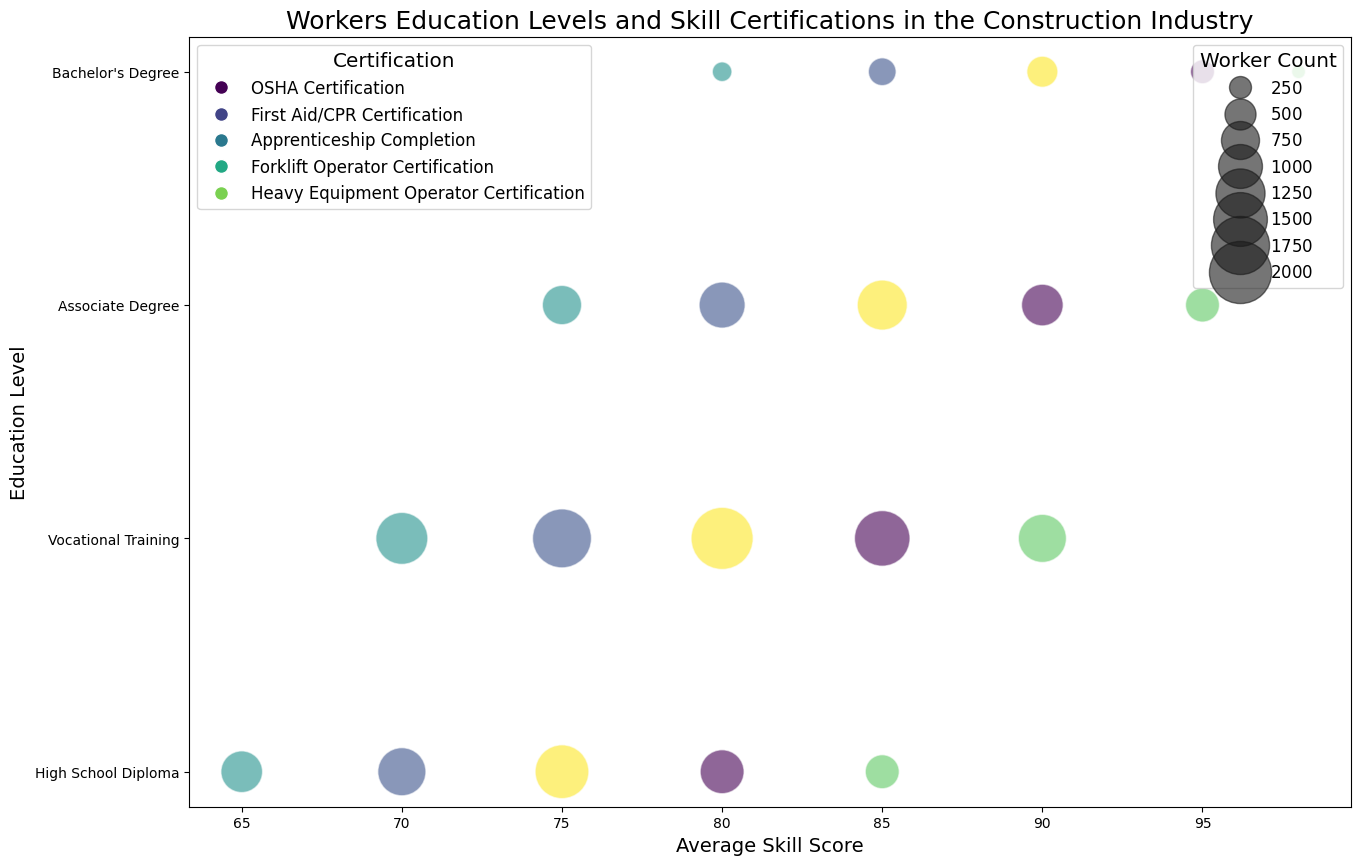Which certification is most common among workers with vocational training? Look for the largest bubble size in the row "Vocational Training." The largest bubble corresponds to "OSHA Certification" with 200 workers.
Answer: OSHA Certification What is the highest average skill score for workers with a bachelor's degree? Check for the maximum value on the x-axis among all bubbles in the "Bachelor's Degree" row. The highest value is 98 for "Heavy Equipment Operator Certification."
Answer: 98 Which education level has the highest average skill score for First Aid/CPR Certification? Compare the positions along the x-axis for "First Aid/CPR Certification" across all education levels. "Bachelor's Degree" has the highest score at 85.
Answer: Bachelor's Degree Between "High School Diploma" and "Associate Degree," which has more workers with Heavy Equipment Operator Certification? Compare the bubble sizes for "High School Diploma" and "Associate Degree" in the "Heavy Equipment Operator Certification" category. "High School Diploma" has 60 workers, and "Associate Degree" has 60 workers.
Answer: Equal What is the total number of workers with OSHA Certification across all education levels? Add the number of workers in the "OSHA Certification" category for all education levels: 150 + 200 + 130 + 50 = 530 workers.
Answer: 530 How much higher is the average skill score for workers with an Associate Degree and Heavy Equipment Operator Certification compared to those with a High School Diploma and the same certification? Subtract the average skill score for "High School Diploma" (85) from "Associate Degree" (95) for "Heavy Equipment Operator Certification." 95 - 85 = 10.
Answer: 10 Which education level has the smallest total number of workers? Sum the number of workers for each education level and identify the smallest sum: High School Diploma (520), Vocational Training (800), Associate Degree (470), Bachelor's Degree (150). "Bachelor's Degree" has the smallest total, 150.
Answer: Bachelor's Degree What is the difference in average skill scores between the highest and lowest scoring certifications for workers with a Vocational Training background? Compare the highest (Heavy Equipment Operator Certification, 90) and lowest (Forklift Operator Certification, 70) skill scores in the "Vocational Training" row. 90 - 70 = 20.
Answer: 20 